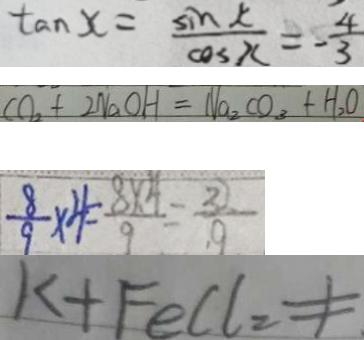Convert formula to latex. <formula><loc_0><loc_0><loc_500><loc_500>\tan x = \frac { \sin x } { \cos x } = - \frac { 4 } { 3 } 
 C O _ { 2 } + 2 N a O H = N a _ { 2 } C O _ { 3 } + H _ { 2 } O 
 \frac { 8 } { 9 } \times 4 = \frac { 8 \times 4 } { 9 } = \frac { 3 } { 9 } 
 K + F e C l _ { 2 } \neq</formula> 